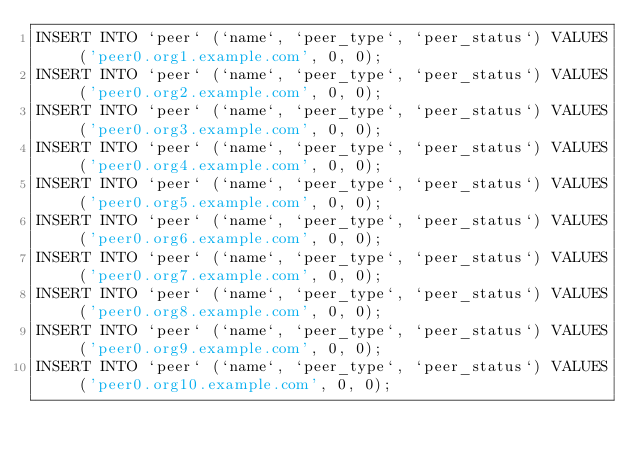<code> <loc_0><loc_0><loc_500><loc_500><_SQL_>INSERT INTO `peer` (`name`, `peer_type`, `peer_status`) VALUES ('peer0.org1.example.com', 0, 0);
INSERT INTO `peer` (`name`, `peer_type`, `peer_status`) VALUES ('peer0.org2.example.com', 0, 0);
INSERT INTO `peer` (`name`, `peer_type`, `peer_status`) VALUES ('peer0.org3.example.com', 0, 0);
INSERT INTO `peer` (`name`, `peer_type`, `peer_status`) VALUES ('peer0.org4.example.com', 0, 0);
INSERT INTO `peer` (`name`, `peer_type`, `peer_status`) VALUES ('peer0.org5.example.com', 0, 0);
INSERT INTO `peer` (`name`, `peer_type`, `peer_status`) VALUES ('peer0.org6.example.com', 0, 0);
INSERT INTO `peer` (`name`, `peer_type`, `peer_status`) VALUES ('peer0.org7.example.com', 0, 0);
INSERT INTO `peer` (`name`, `peer_type`, `peer_status`) VALUES ('peer0.org8.example.com', 0, 0);
INSERT INTO `peer` (`name`, `peer_type`, `peer_status`) VALUES ('peer0.org9.example.com', 0, 0);
INSERT INTO `peer` (`name`, `peer_type`, `peer_status`) VALUES ('peer0.org10.example.com', 0, 0);
</code> 